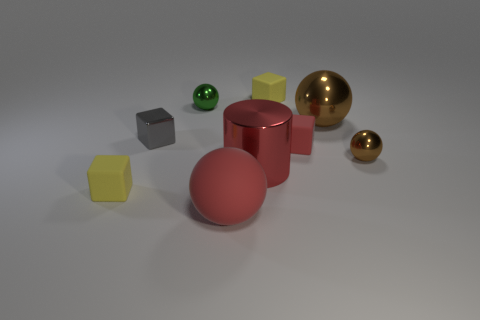Is there anything else that is the same shape as the large red metal thing?
Give a very brief answer. No. How many big brown things have the same shape as the gray metallic object?
Your answer should be compact. 0. What number of red matte balls are there?
Provide a succinct answer. 1. What is the color of the block behind the green metal sphere?
Keep it short and to the point. Yellow. There is a sphere that is in front of the small yellow thing that is in front of the gray cube; what is its color?
Your answer should be very brief. Red. There is a metal cube that is the same size as the green metal sphere; what color is it?
Ensure brevity in your answer.  Gray. How many objects are on the left side of the small green object and in front of the small gray object?
Your response must be concise. 1. What shape is the small matte thing that is the same color as the big cylinder?
Provide a succinct answer. Cube. What material is the small object that is both behind the large brown metal ball and on the right side of the red cylinder?
Offer a terse response. Rubber. Are there fewer big red spheres that are on the right side of the tiny metallic block than brown spheres that are behind the large red cylinder?
Make the answer very short. Yes. 